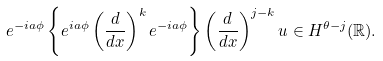Convert formula to latex. <formula><loc_0><loc_0><loc_500><loc_500>e ^ { - i a \phi } \left \{ e ^ { i a \phi } \left ( \frac { d } { d x } \right ) ^ { k } e ^ { - i a \phi } \right \} \left ( \frac { d } { d x } \right ) ^ { j - k } u \in H ^ { \theta - j } ( \mathbb { R } ) .</formula> 